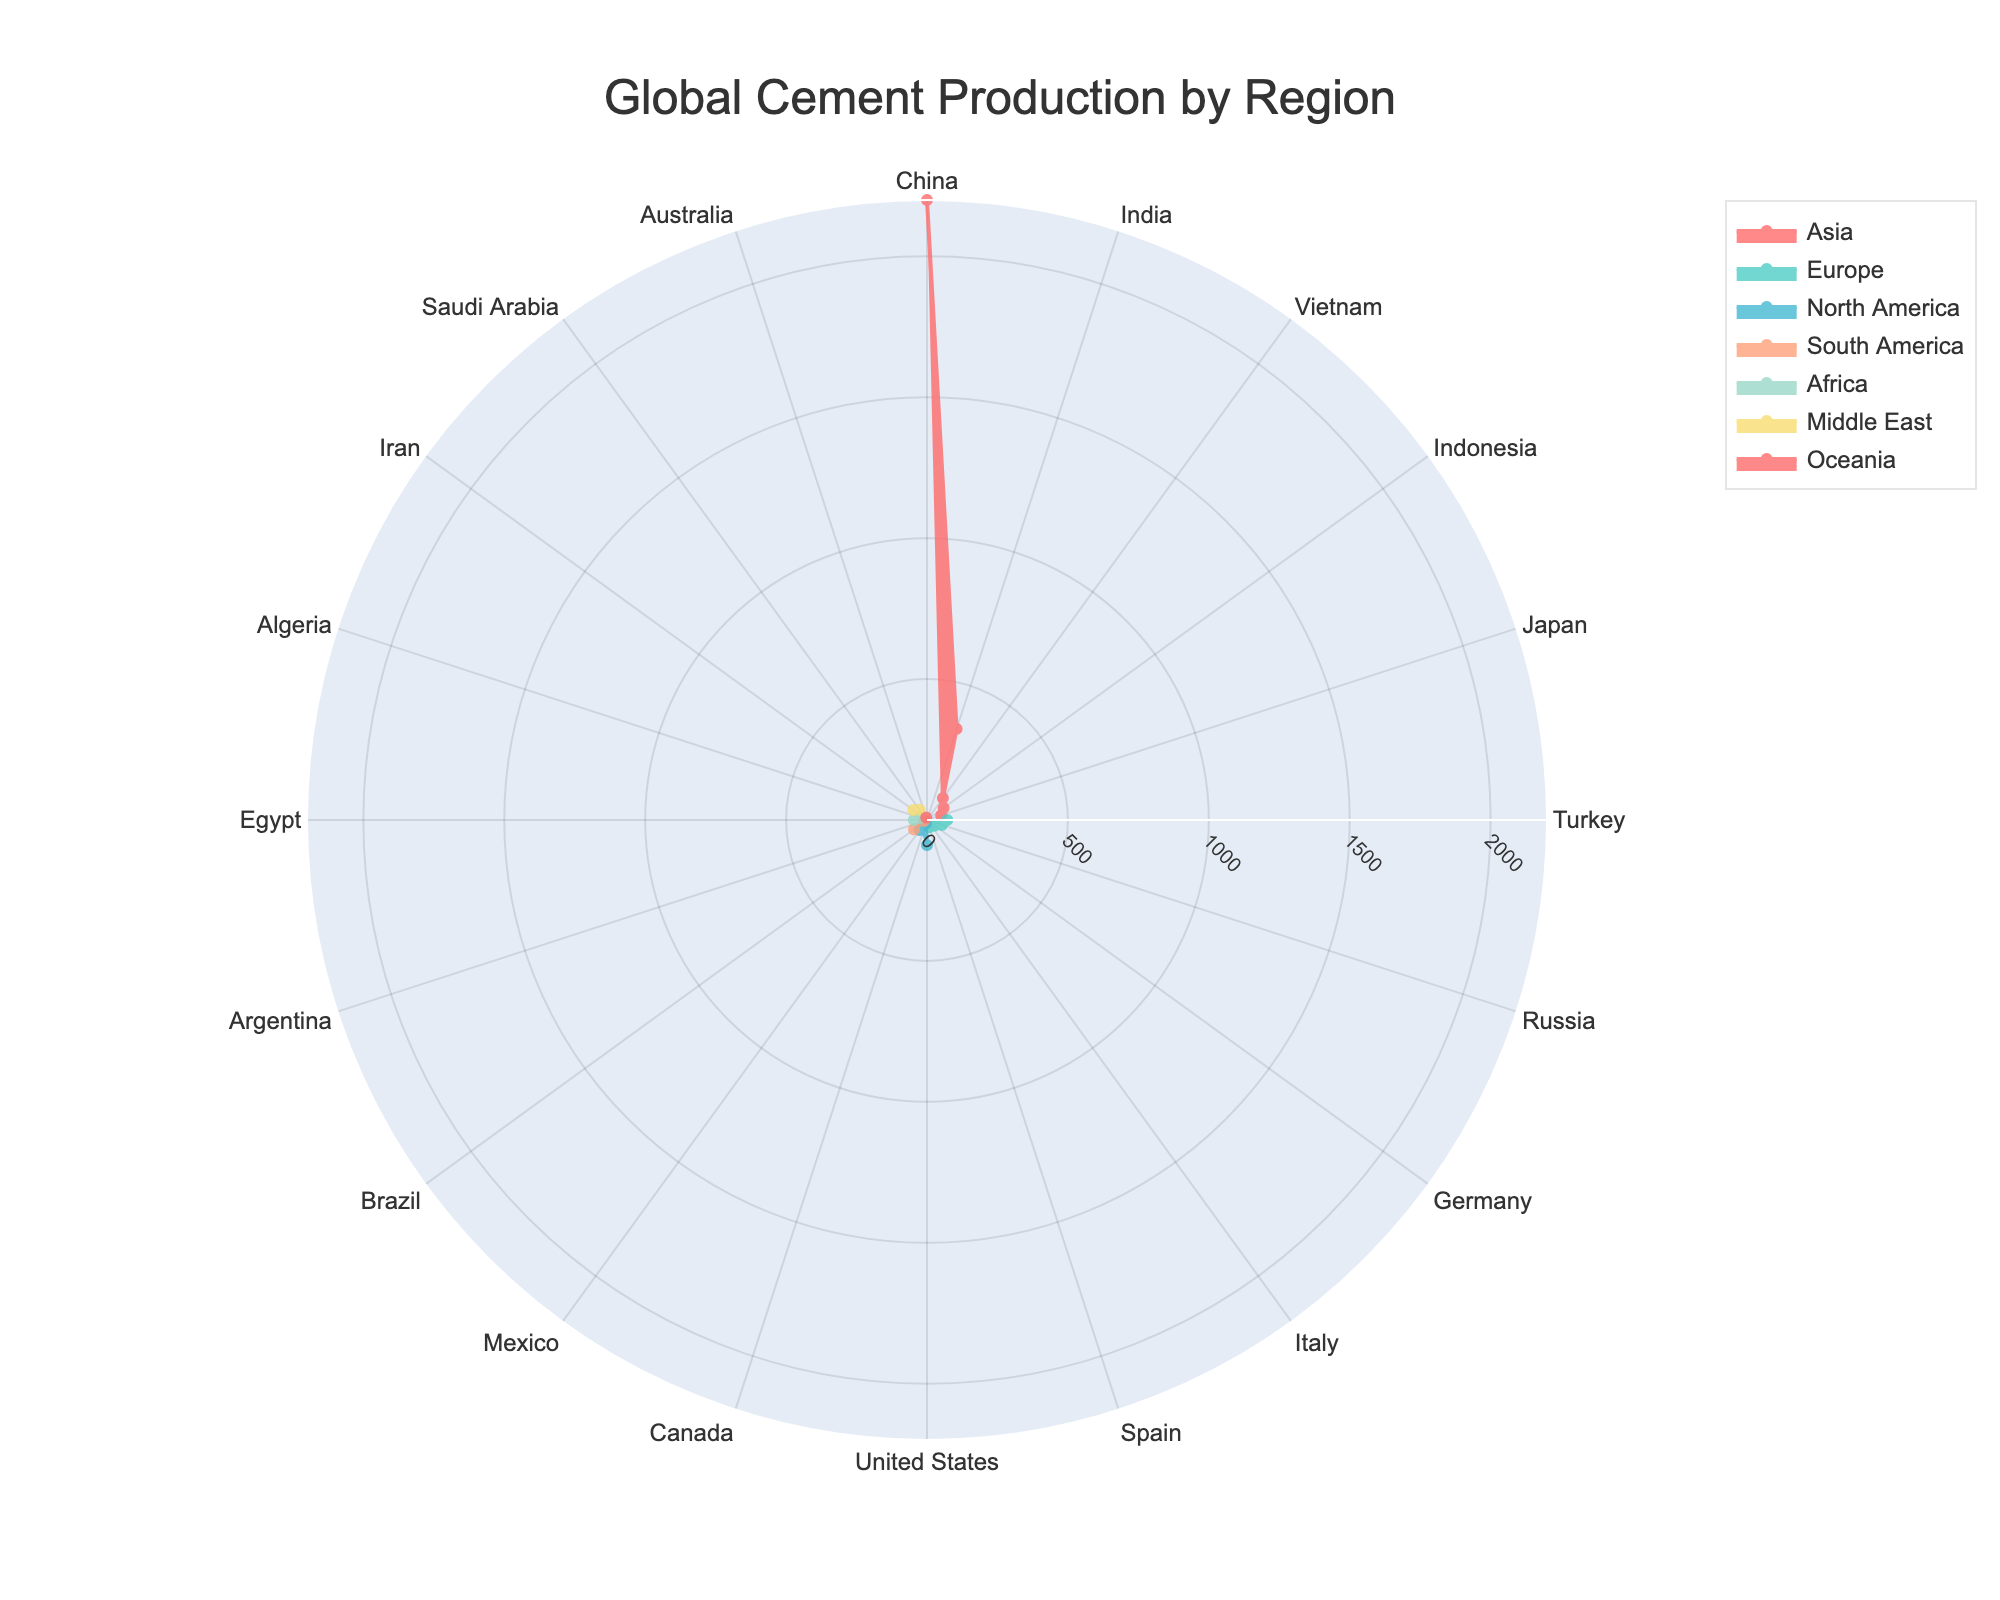What's the title of the figure? The title is located at the top center of the figure. It reads "Global Cement Production by Region".
Answer: Global Cement Production by Region How many regions are represented in the figure? Count the unique categories listed in the legend or the distinct colors/shapes of the data traces.
Answer: 7 Which country in Asia produces the most cement? By examining the "Asia" section, we look for the country with the longest radial distance from the center. China has the longest bar.
Answer: China What is the production difference between the top-producing countries in North America and Europe? Identify the top producers in each region (United States for North America and Turkey for Europe) and subtract their productions: 89 (USA) - 72 (Turkey) = 17 million tonnes.
Answer: 17 million tonnes Which regions have more than one country producing over 50 million tonnes of cement? Check each region's countries and their production values. Both Asia and North America have multiple countries with more than 50 million tonnes.
Answer: Asia, North America Rank the top three countries in cement production from highest to lowest. Order the countries based on their production values: China (2200), India (340), United States (89).
Answer: China, India, United States How does the cement production of Iran compare to that of Indonesia? Locate both countries and their respective production values. Iran has 60 million tonnes while Indonesia has 73. Indonesia's production is higher.
Answer: Indonesia produces more than Iran What is the combined cement production of Brazil and Mexico? Sum the production amounts of Brazil and Mexico: 57 (Brazil) + 44 (Mexico) = 101 million tonnes.
Answer: 101 million tonnes Which region has the least total production based on the visible data? By summing all the countries' productions in each region, Oceania, with only Australia's 9 million tonnes, has the least total production.
Answer: Oceania 